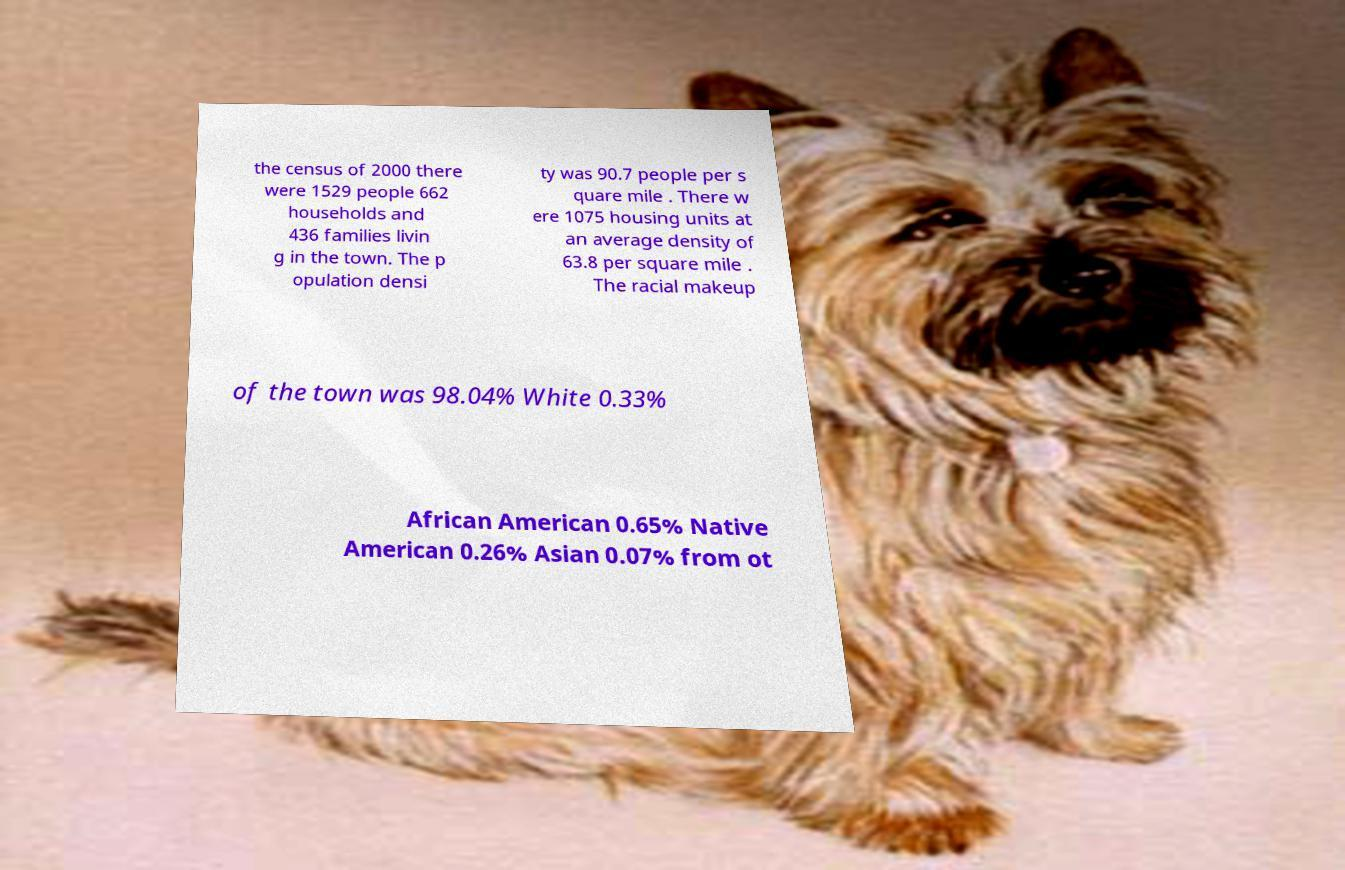Please read and relay the text visible in this image. What does it say? the census of 2000 there were 1529 people 662 households and 436 families livin g in the town. The p opulation densi ty was 90.7 people per s quare mile . There w ere 1075 housing units at an average density of 63.8 per square mile . The racial makeup of the town was 98.04% White 0.33% African American 0.65% Native American 0.26% Asian 0.07% from ot 